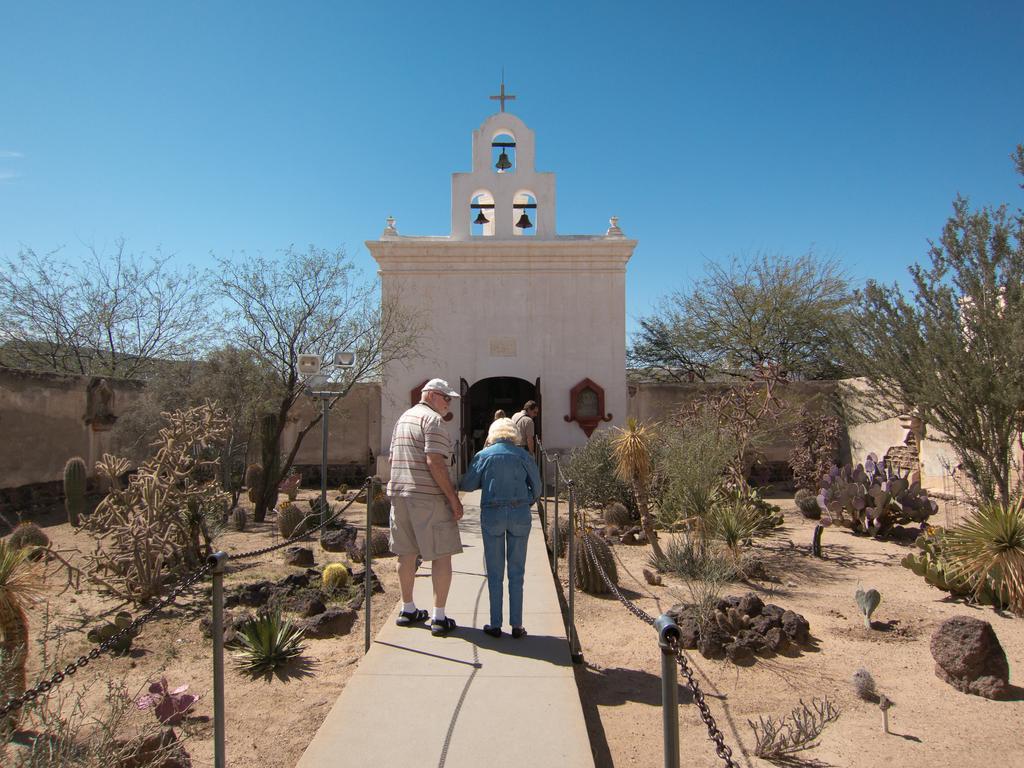Could you give a brief overview of what you see in this image? In this image there are a few people walking on the pavement, beside the pavement there are trees and rocks, in the background of the image there is a wall with a cross on it. 